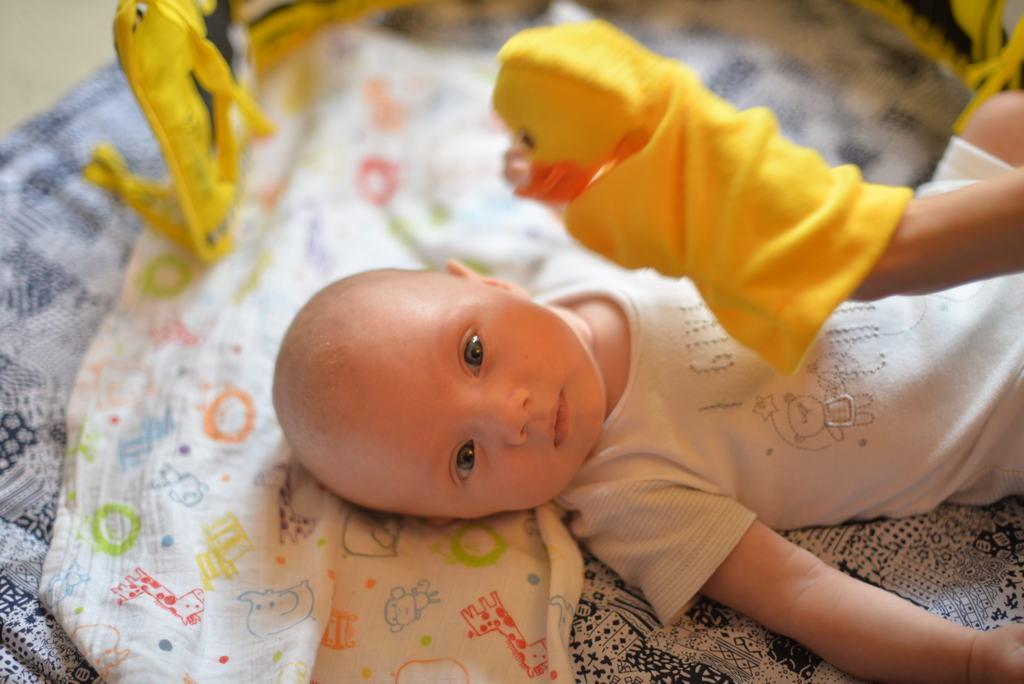Could you give a brief overview of what you see in this image? In the center of the image there is a cloth. On the cloth, we can see one baby is lying. And we can see one human hand with a hand puppet. In the background, we can see one yellow color object. 